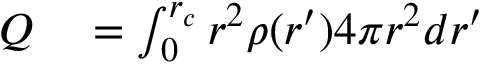Convert formula to latex. <formula><loc_0><loc_0><loc_500><loc_500>\begin{array} { r l } { Q } & = \int _ { 0 } ^ { r _ { c } } r ^ { 2 } \rho ( r ^ { \prime } ) 4 \pi r ^ { 2 } d r ^ { \prime } } \end{array}</formula> 